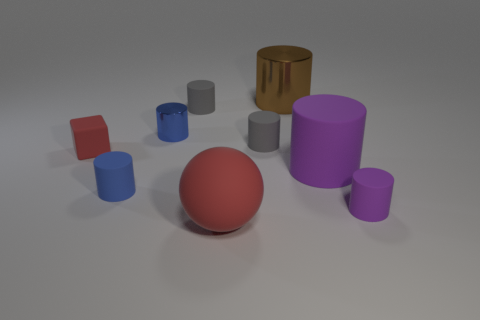What size is the rubber thing that is the same color as the ball?
Give a very brief answer. Small. There is a big purple object that is the same material as the red cube; what is its shape?
Offer a terse response. Cylinder. What number of things are both behind the large purple rubber cylinder and left of the big shiny object?
Your response must be concise. 4. Are there any blue rubber things behind the blue matte cylinder?
Make the answer very short. No. There is a tiny blue object left of the blue shiny thing; does it have the same shape as the purple matte thing on the left side of the tiny purple matte object?
Your answer should be compact. Yes. How many things are either big red rubber spheres or small blue objects to the right of the red matte block?
Your answer should be very brief. 3. How many other objects are the same shape as the small purple object?
Provide a short and direct response. 6. Is the tiny blue thing that is in front of the tiny red cube made of the same material as the small red object?
Provide a short and direct response. Yes. How many objects are either small shiny cylinders or large yellow metallic spheres?
Ensure brevity in your answer.  1. The other blue thing that is the same shape as the tiny metallic object is what size?
Offer a terse response. Small. 